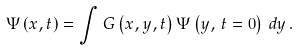Convert formula to latex. <formula><loc_0><loc_0><loc_500><loc_500>\Psi \left ( x , t \right ) = \int G \left ( x , y , t \right ) \Psi \left ( y , \, t = 0 \right ) \, d y \, .</formula> 